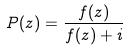<formula> <loc_0><loc_0><loc_500><loc_500>P ( z ) = \frac { f ( z ) } { f ( z ) + i }</formula> 